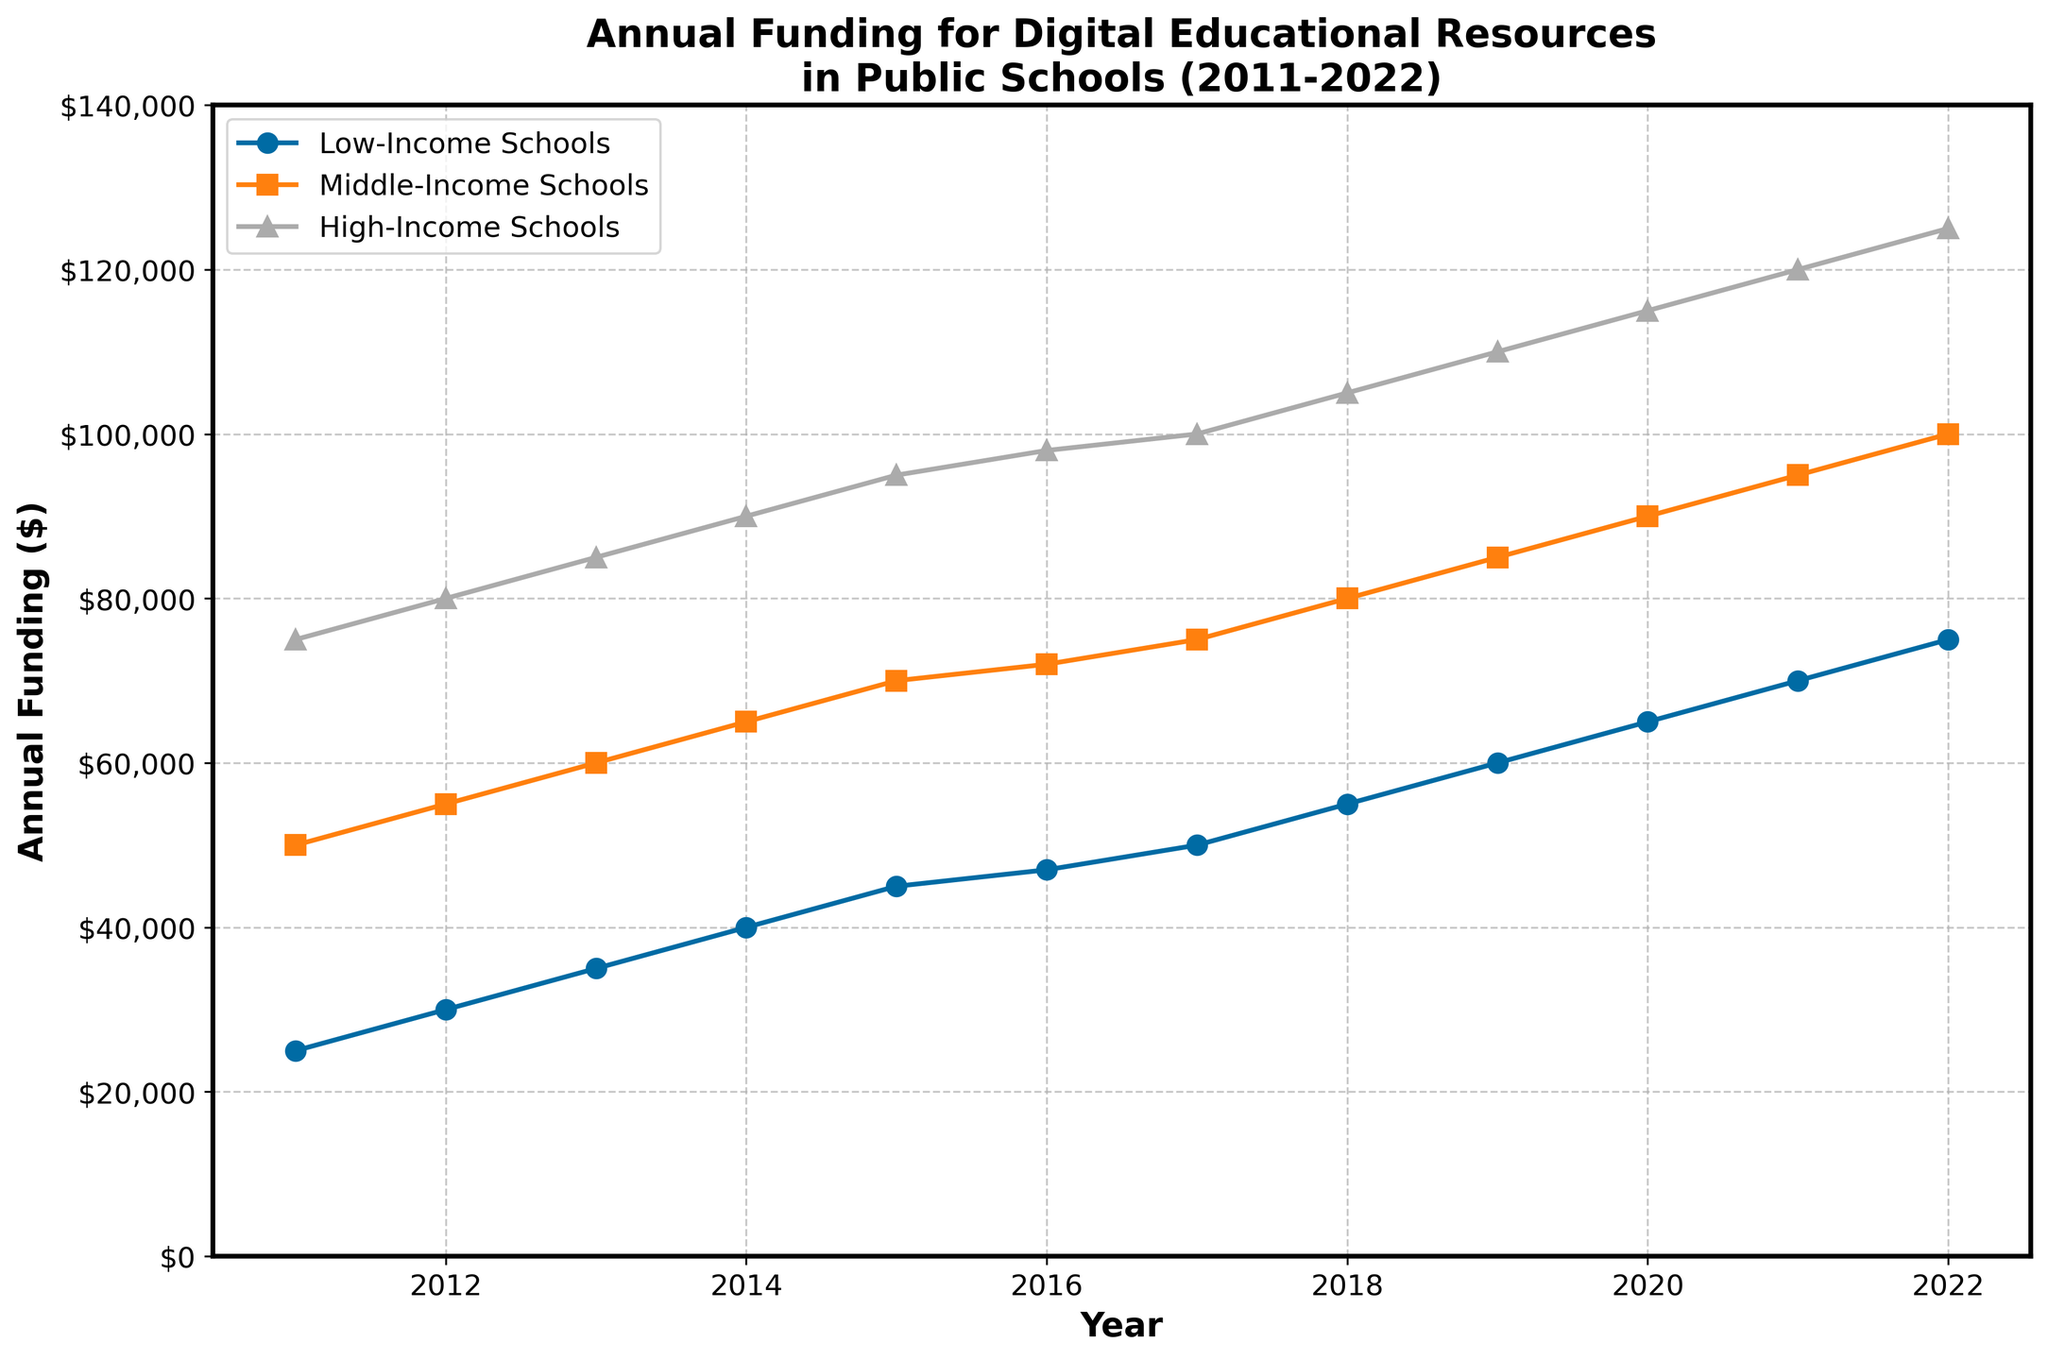How many categories of schools are shown in the figure? There are three distinct lines in the plot, each representing a different category of schools. Based on the legend, these categories are Low-Income Schools, Middle-Income Schools, and High-Income Schools.
Answer: 3 What is the title of the figure? The title is prominently displayed at the top of the plot, summarizing the content of the figure. The title is "Annual Funding for Digital Educational Resources in Public Schools (2011-2022)".
Answer: Annual Funding for Digital Educational Resources in Public Schools (2011-2022) How much funding did Low-Income Schools receive in 2018? By following the Low-Income Schools line (marked with circles) to the year 2018 on the x-axis, and then reading the corresponding y-axis value, you can see that Low-Income Schools received $55,000 in 2018.
Answer: $55,000 Which category of schools had the highest funding in 2022, and how much was it? By comparing the values of all three lines for the year 2022, the highest value is for the High-Income Schools (marked with triangles), which received $125,000.
Answer: High-Income Schools, $125,000 What is the difference in funding between Middle-Income and Low-Income Schools in 2015? For 2015, the funding for Middle-Income Schools is $70,000 and for Low-Income Schools is $45,000. The difference is calculated by subtracting $45,000 from $70,000.
Answer: $25,000 Which school category shows the most significant increase in funding from 2011 to 2022? To determine the most significant increase, calculate the difference in funding from 2011 to 2022 for each category: 
- Low-Income Schools: $75,000 - $25,000 = $50,000
- Middle-Income Schools: $100,000 - $50,000 = $50,000
- High-Income Schools: $125,000 - $75,000 = $50,000
All categories show an equal increase of $50,000, so the increase is the same for all.
Answer: All categories, $50,000 What trend can be observed in the funding of High-Income Schools over the years? Observing the line for High-Income Schools (marked with triangles) reveals a general upward trend, indicating that funding has increased steadily each year from 2011 to 2022.
Answer: Upward trend In which year did Middle-Income Schools reach $80,000 in annual funding? By following the Middle-Income Schools line (marked with squares) to find where it intersects the y-axis value of $80,000, this occurs in the year 2018.
Answer: 2018 How does the rate of funding increase compare among the three categories over the observed period? To compare the rate of increase, calculate the average yearly increment for each category over the period 2011-2022: 
- Low-Income: ($75,000 - $25,000) / 11 = $4,545.45/year
- Middle-Income: ($100,000 - $50,000) / 11 = $4,545.45/year
- High-Income: ($125,000 - $75,000) / 11 = $4,545.45/year
All categories have the same average yearly increment of $4,545.45.
Answer: Same rate, $4,545.45/year 